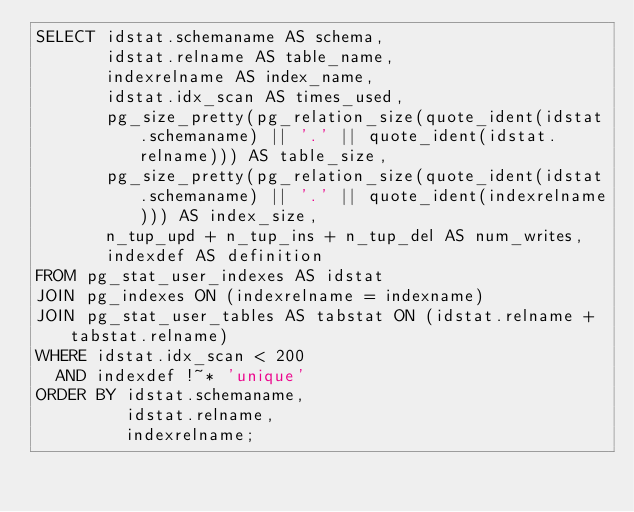Convert code to text. <code><loc_0><loc_0><loc_500><loc_500><_SQL_>SELECT idstat.schemaname AS schema,
       idstat.relname AS table_name,
       indexrelname AS index_name,
       idstat.idx_scan AS times_used,
       pg_size_pretty(pg_relation_size(quote_ident(idstat.schemaname) || '.' || quote_ident(idstat.relname))) AS table_size,
       pg_size_pretty(pg_relation_size(quote_ident(idstat.schemaname) || '.' || quote_ident(indexrelname))) AS index_size,
       n_tup_upd + n_tup_ins + n_tup_del AS num_writes,
       indexdef AS definition
FROM pg_stat_user_indexes AS idstat
JOIN pg_indexes ON (indexrelname = indexname)
JOIN pg_stat_user_tables AS tabstat ON (idstat.relname + tabstat.relname)
WHERE idstat.idx_scan < 200
  AND indexdef !~* 'unique'
ORDER BY idstat.schemaname,
         idstat.relname,
         indexrelname;</code> 